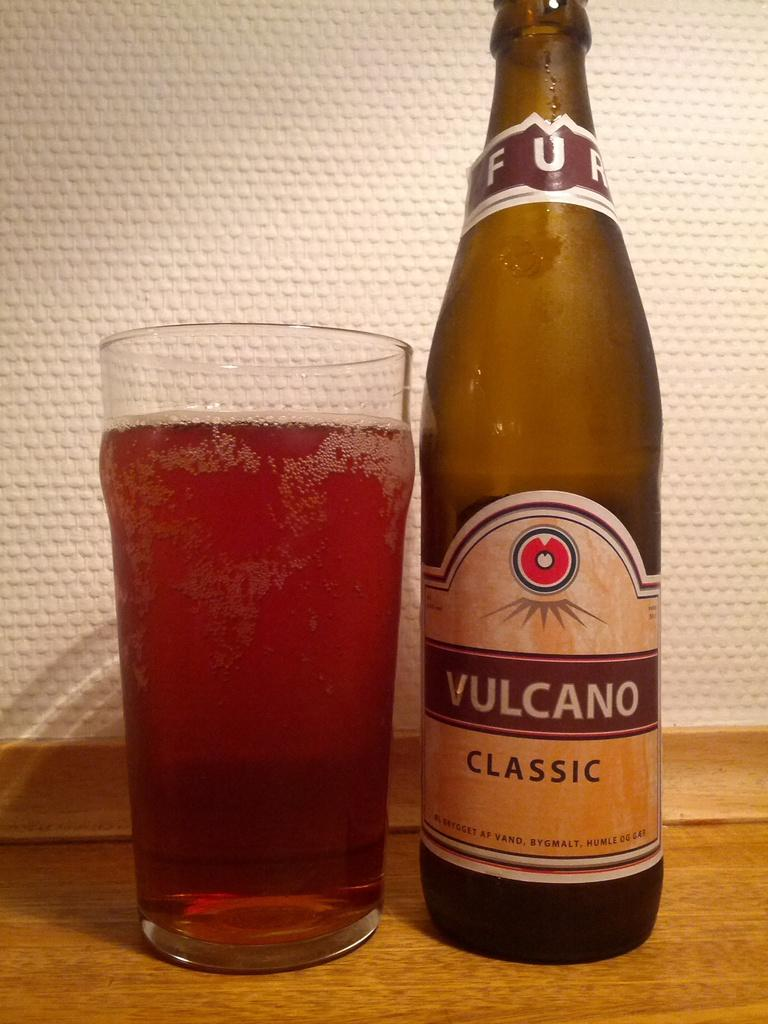Provide a one-sentence caption for the provided image. A bottle of beer next to a glass of beer, the bottle reading Vulcano classic. 